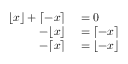Convert formula to latex. <formula><loc_0><loc_0><loc_500><loc_500>\begin{array} { r l } { \lfloor x \rfloor + \lceil - x \rceil } & = 0 } \\ { - \lfloor x \rfloor } & = \lceil - x \rceil } \\ { - \lceil x \rceil } & = \lfloor - x \rfloor } \end{array}</formula> 